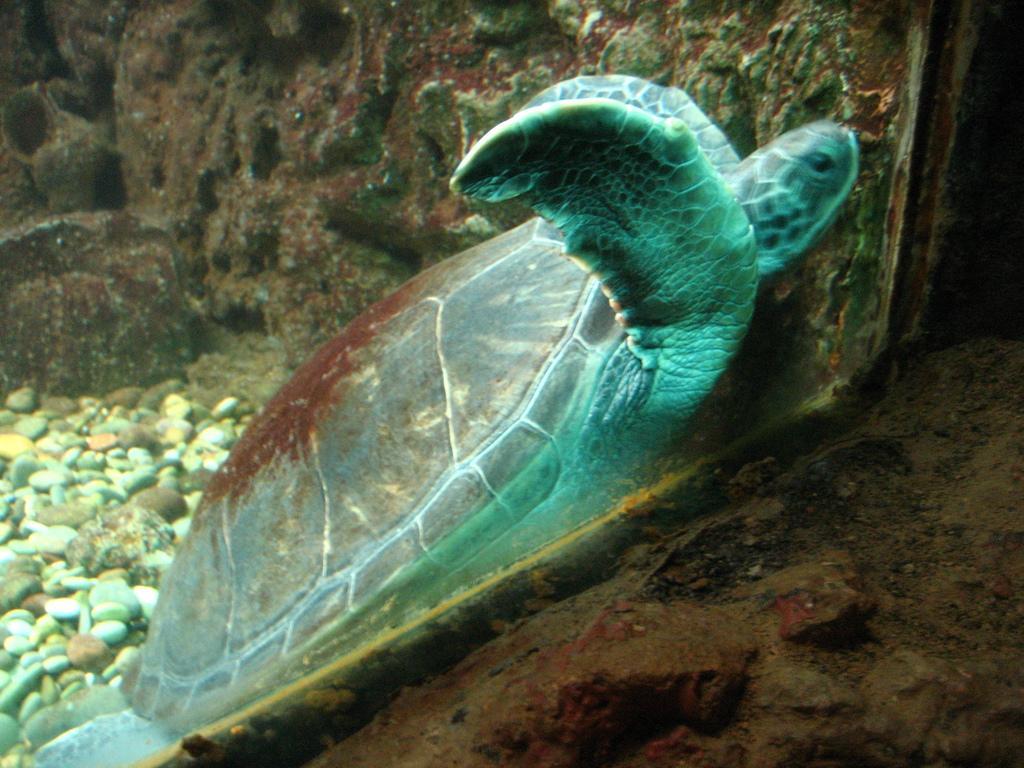Please provide a concise description of this image. In the picture I can see a tortoise, stones and a glass wall. 